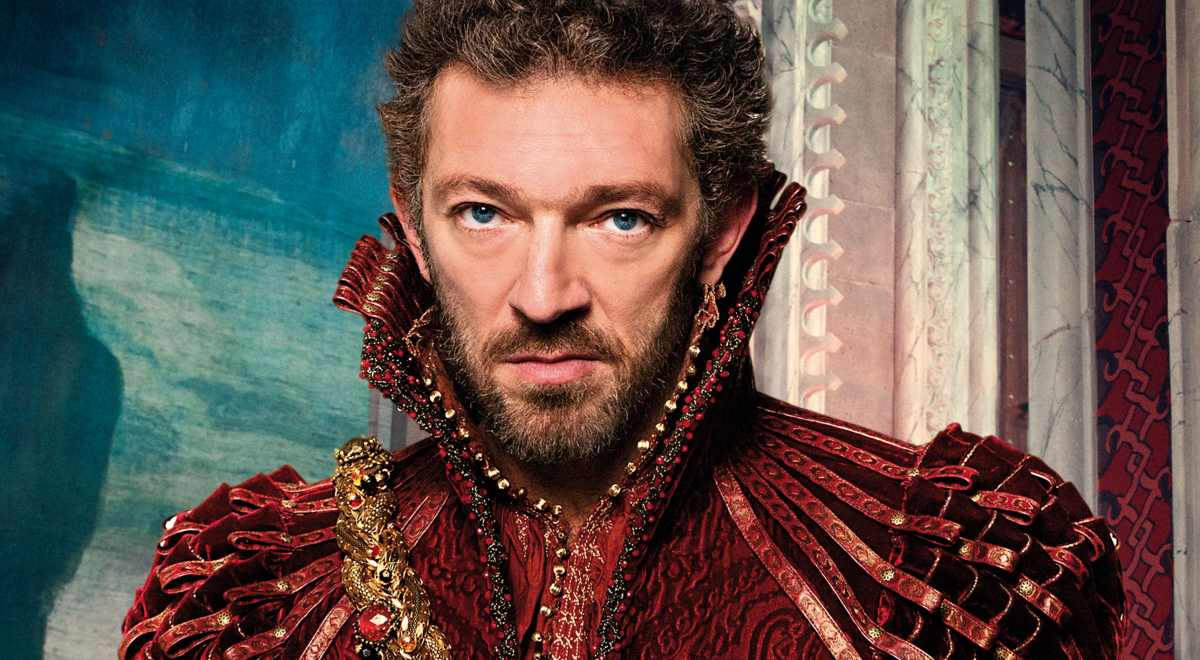Imagine a magical element to this scene. As twilight descended upon the fortress, the air around Duke Alaric began to shimmer with an ethereal light. The gold detailing on his costume glowed softly, and his eyes shone with an otherworldly intensity. Alaric was not merely a man of power but a guardian of ancient magic. The curtains behind him swayed gently though there was no breeze, and faint whispers of arcane incantations filled the room. As Alaric raised his arm, a golden aura encircled his silhouette, and with a flick of his wrist, he summoned protective spells that reinforced the fortress walls, ensuring that no dark forces could penetrate the stronghold that night. 